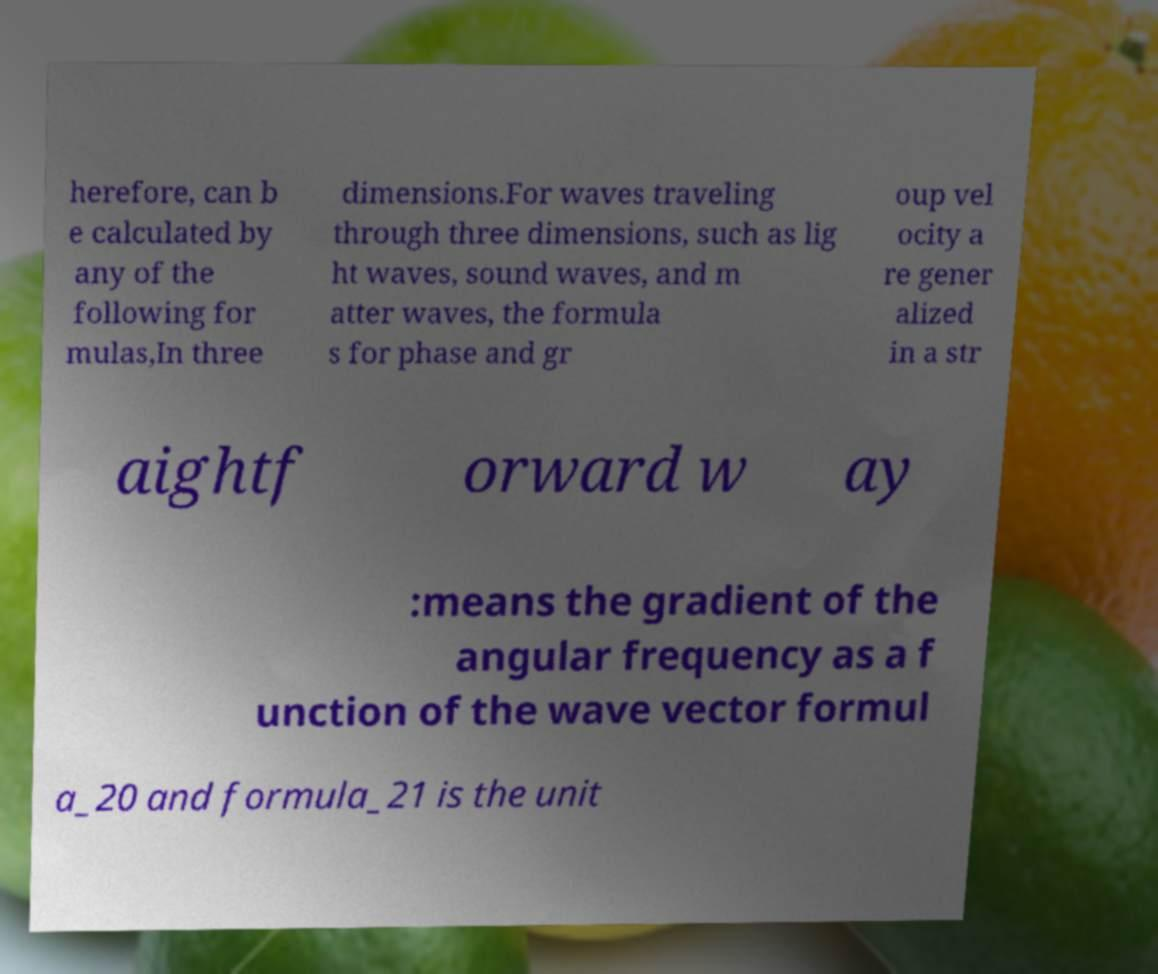Please read and relay the text visible in this image. What does it say? herefore, can b e calculated by any of the following for mulas,In three dimensions.For waves traveling through three dimensions, such as lig ht waves, sound waves, and m atter waves, the formula s for phase and gr oup vel ocity a re gener alized in a str aightf orward w ay :means the gradient of the angular frequency as a f unction of the wave vector formul a_20 and formula_21 is the unit 